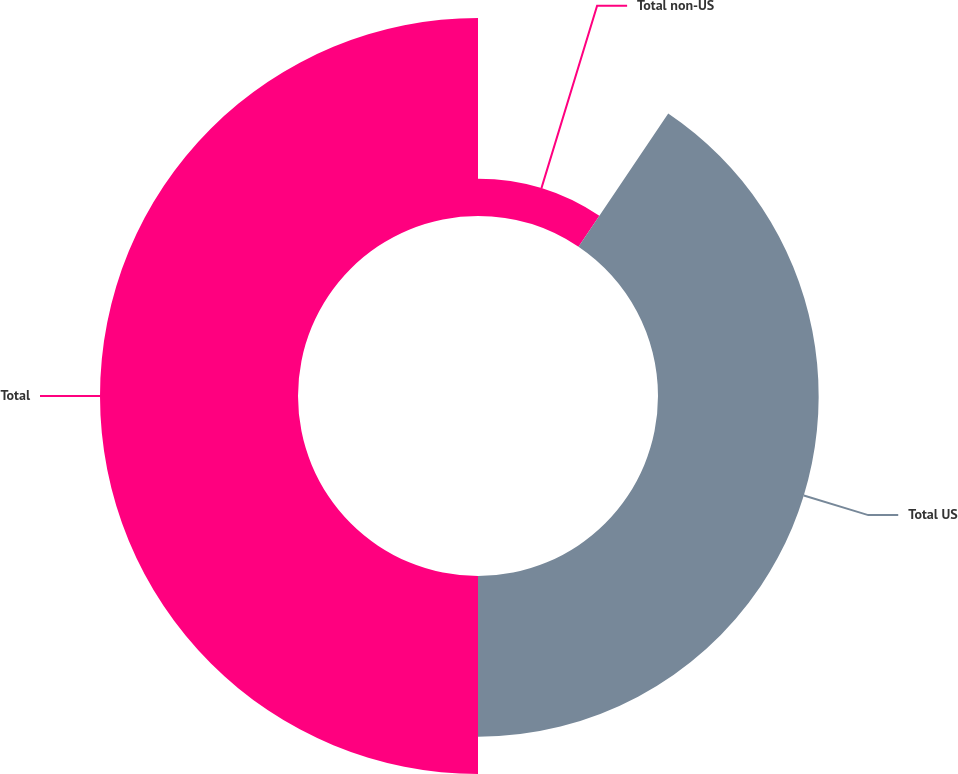Convert chart to OTSL. <chart><loc_0><loc_0><loc_500><loc_500><pie_chart><fcel>Total non-US<fcel>Total US<fcel>Total<nl><fcel>9.43%<fcel>40.57%<fcel>50.0%<nl></chart> 